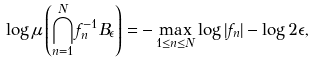<formula> <loc_0><loc_0><loc_500><loc_500>\log \mu \left ( \bigcap _ { n = 1 } ^ { N } f _ { n } ^ { - 1 } B _ { \epsilon } \right ) = - \max _ { 1 \leq n \leq N } \log | f _ { n } | - \log 2 \epsilon ,</formula> 